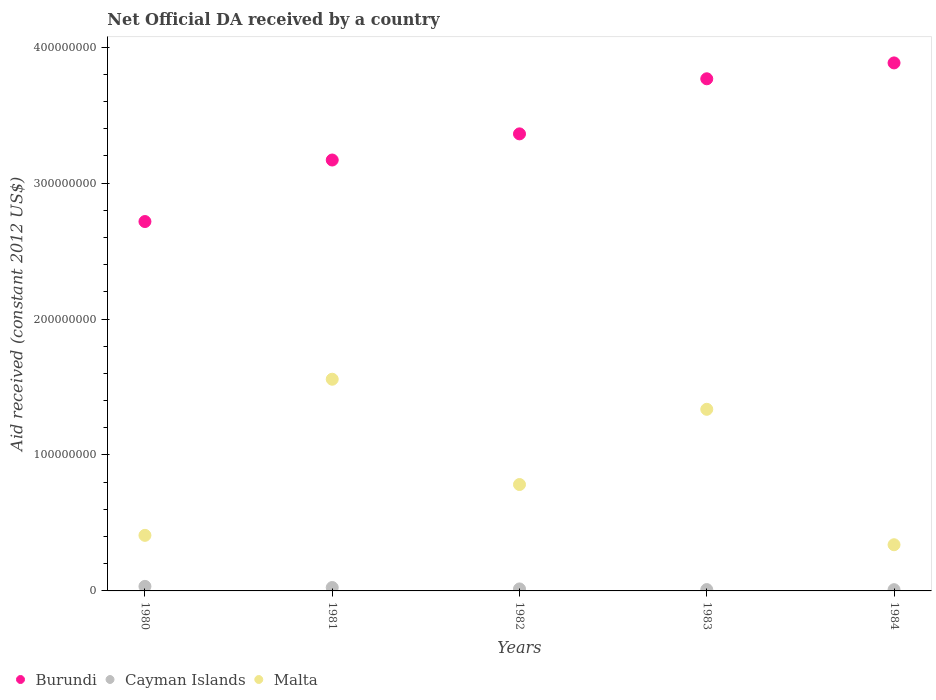Is the number of dotlines equal to the number of legend labels?
Your answer should be compact. Yes. What is the net official development assistance aid received in Cayman Islands in 1981?
Make the answer very short. 2.50e+06. Across all years, what is the maximum net official development assistance aid received in Cayman Islands?
Give a very brief answer. 3.34e+06. Across all years, what is the minimum net official development assistance aid received in Cayman Islands?
Give a very brief answer. 9.20e+05. What is the total net official development assistance aid received in Cayman Islands in the graph?
Your answer should be very brief. 9.21e+06. What is the difference between the net official development assistance aid received in Burundi in 1982 and that in 1984?
Provide a succinct answer. -5.22e+07. What is the difference between the net official development assistance aid received in Cayman Islands in 1981 and the net official development assistance aid received in Malta in 1980?
Make the answer very short. -3.84e+07. What is the average net official development assistance aid received in Burundi per year?
Provide a short and direct response. 3.38e+08. In the year 1984, what is the difference between the net official development assistance aid received in Cayman Islands and net official development assistance aid received in Burundi?
Offer a very short reply. -3.87e+08. What is the ratio of the net official development assistance aid received in Cayman Islands in 1980 to that in 1982?
Offer a terse response. 2.27. Is the net official development assistance aid received in Burundi in 1980 less than that in 1983?
Make the answer very short. Yes. Is the difference between the net official development assistance aid received in Cayman Islands in 1980 and 1981 greater than the difference between the net official development assistance aid received in Burundi in 1980 and 1981?
Offer a terse response. Yes. What is the difference between the highest and the second highest net official development assistance aid received in Cayman Islands?
Your answer should be very brief. 8.40e+05. What is the difference between the highest and the lowest net official development assistance aid received in Malta?
Provide a succinct answer. 1.22e+08. Is the sum of the net official development assistance aid received in Malta in 1980 and 1983 greater than the maximum net official development assistance aid received in Cayman Islands across all years?
Provide a succinct answer. Yes. Is it the case that in every year, the sum of the net official development assistance aid received in Cayman Islands and net official development assistance aid received in Burundi  is greater than the net official development assistance aid received in Malta?
Ensure brevity in your answer.  Yes. Is the net official development assistance aid received in Burundi strictly greater than the net official development assistance aid received in Cayman Islands over the years?
Keep it short and to the point. Yes. How many dotlines are there?
Provide a succinct answer. 3. How many years are there in the graph?
Offer a very short reply. 5. What is the difference between two consecutive major ticks on the Y-axis?
Your answer should be compact. 1.00e+08. Does the graph contain any zero values?
Provide a succinct answer. No. How many legend labels are there?
Offer a terse response. 3. How are the legend labels stacked?
Give a very brief answer. Horizontal. What is the title of the graph?
Keep it short and to the point. Net Official DA received by a country. Does "Sint Maarten (Dutch part)" appear as one of the legend labels in the graph?
Keep it short and to the point. No. What is the label or title of the Y-axis?
Your answer should be very brief. Aid received (constant 2012 US$). What is the Aid received (constant 2012 US$) of Burundi in 1980?
Offer a terse response. 2.72e+08. What is the Aid received (constant 2012 US$) in Cayman Islands in 1980?
Make the answer very short. 3.34e+06. What is the Aid received (constant 2012 US$) of Malta in 1980?
Give a very brief answer. 4.09e+07. What is the Aid received (constant 2012 US$) of Burundi in 1981?
Keep it short and to the point. 3.17e+08. What is the Aid received (constant 2012 US$) of Cayman Islands in 1981?
Provide a short and direct response. 2.50e+06. What is the Aid received (constant 2012 US$) of Malta in 1981?
Ensure brevity in your answer.  1.56e+08. What is the Aid received (constant 2012 US$) in Burundi in 1982?
Give a very brief answer. 3.36e+08. What is the Aid received (constant 2012 US$) in Cayman Islands in 1982?
Your answer should be very brief. 1.47e+06. What is the Aid received (constant 2012 US$) of Malta in 1982?
Offer a very short reply. 7.83e+07. What is the Aid received (constant 2012 US$) in Burundi in 1983?
Provide a succinct answer. 3.77e+08. What is the Aid received (constant 2012 US$) of Cayman Islands in 1983?
Offer a very short reply. 9.80e+05. What is the Aid received (constant 2012 US$) in Malta in 1983?
Provide a succinct answer. 1.34e+08. What is the Aid received (constant 2012 US$) in Burundi in 1984?
Give a very brief answer. 3.88e+08. What is the Aid received (constant 2012 US$) in Cayman Islands in 1984?
Give a very brief answer. 9.20e+05. What is the Aid received (constant 2012 US$) of Malta in 1984?
Your response must be concise. 3.40e+07. Across all years, what is the maximum Aid received (constant 2012 US$) in Burundi?
Your answer should be compact. 3.88e+08. Across all years, what is the maximum Aid received (constant 2012 US$) in Cayman Islands?
Provide a succinct answer. 3.34e+06. Across all years, what is the maximum Aid received (constant 2012 US$) in Malta?
Provide a succinct answer. 1.56e+08. Across all years, what is the minimum Aid received (constant 2012 US$) of Burundi?
Your answer should be very brief. 2.72e+08. Across all years, what is the minimum Aid received (constant 2012 US$) in Cayman Islands?
Make the answer very short. 9.20e+05. Across all years, what is the minimum Aid received (constant 2012 US$) of Malta?
Offer a very short reply. 3.40e+07. What is the total Aid received (constant 2012 US$) in Burundi in the graph?
Keep it short and to the point. 1.69e+09. What is the total Aid received (constant 2012 US$) of Cayman Islands in the graph?
Your answer should be very brief. 9.21e+06. What is the total Aid received (constant 2012 US$) of Malta in the graph?
Keep it short and to the point. 4.42e+08. What is the difference between the Aid received (constant 2012 US$) of Burundi in 1980 and that in 1981?
Provide a short and direct response. -4.52e+07. What is the difference between the Aid received (constant 2012 US$) of Cayman Islands in 1980 and that in 1981?
Make the answer very short. 8.40e+05. What is the difference between the Aid received (constant 2012 US$) in Malta in 1980 and that in 1981?
Offer a terse response. -1.15e+08. What is the difference between the Aid received (constant 2012 US$) in Burundi in 1980 and that in 1982?
Ensure brevity in your answer.  -6.45e+07. What is the difference between the Aid received (constant 2012 US$) in Cayman Islands in 1980 and that in 1982?
Offer a terse response. 1.87e+06. What is the difference between the Aid received (constant 2012 US$) of Malta in 1980 and that in 1982?
Offer a terse response. -3.74e+07. What is the difference between the Aid received (constant 2012 US$) in Burundi in 1980 and that in 1983?
Ensure brevity in your answer.  -1.05e+08. What is the difference between the Aid received (constant 2012 US$) of Cayman Islands in 1980 and that in 1983?
Your answer should be compact. 2.36e+06. What is the difference between the Aid received (constant 2012 US$) of Malta in 1980 and that in 1983?
Provide a short and direct response. -9.27e+07. What is the difference between the Aid received (constant 2012 US$) of Burundi in 1980 and that in 1984?
Provide a short and direct response. -1.17e+08. What is the difference between the Aid received (constant 2012 US$) in Cayman Islands in 1980 and that in 1984?
Provide a short and direct response. 2.42e+06. What is the difference between the Aid received (constant 2012 US$) of Malta in 1980 and that in 1984?
Your answer should be compact. 6.90e+06. What is the difference between the Aid received (constant 2012 US$) in Burundi in 1981 and that in 1982?
Keep it short and to the point. -1.92e+07. What is the difference between the Aid received (constant 2012 US$) of Cayman Islands in 1981 and that in 1982?
Offer a terse response. 1.03e+06. What is the difference between the Aid received (constant 2012 US$) of Malta in 1981 and that in 1982?
Offer a very short reply. 7.74e+07. What is the difference between the Aid received (constant 2012 US$) in Burundi in 1981 and that in 1983?
Ensure brevity in your answer.  -5.97e+07. What is the difference between the Aid received (constant 2012 US$) of Cayman Islands in 1981 and that in 1983?
Provide a short and direct response. 1.52e+06. What is the difference between the Aid received (constant 2012 US$) in Malta in 1981 and that in 1983?
Your answer should be compact. 2.21e+07. What is the difference between the Aid received (constant 2012 US$) of Burundi in 1981 and that in 1984?
Offer a terse response. -7.14e+07. What is the difference between the Aid received (constant 2012 US$) of Cayman Islands in 1981 and that in 1984?
Your answer should be compact. 1.58e+06. What is the difference between the Aid received (constant 2012 US$) in Malta in 1981 and that in 1984?
Provide a short and direct response. 1.22e+08. What is the difference between the Aid received (constant 2012 US$) of Burundi in 1982 and that in 1983?
Ensure brevity in your answer.  -4.05e+07. What is the difference between the Aid received (constant 2012 US$) in Cayman Islands in 1982 and that in 1983?
Your answer should be very brief. 4.90e+05. What is the difference between the Aid received (constant 2012 US$) in Malta in 1982 and that in 1983?
Your response must be concise. -5.53e+07. What is the difference between the Aid received (constant 2012 US$) in Burundi in 1982 and that in 1984?
Your answer should be very brief. -5.22e+07. What is the difference between the Aid received (constant 2012 US$) in Malta in 1982 and that in 1984?
Keep it short and to the point. 4.43e+07. What is the difference between the Aid received (constant 2012 US$) in Burundi in 1983 and that in 1984?
Your answer should be very brief. -1.17e+07. What is the difference between the Aid received (constant 2012 US$) of Cayman Islands in 1983 and that in 1984?
Provide a succinct answer. 6.00e+04. What is the difference between the Aid received (constant 2012 US$) in Malta in 1983 and that in 1984?
Provide a short and direct response. 9.96e+07. What is the difference between the Aid received (constant 2012 US$) in Burundi in 1980 and the Aid received (constant 2012 US$) in Cayman Islands in 1981?
Make the answer very short. 2.69e+08. What is the difference between the Aid received (constant 2012 US$) in Burundi in 1980 and the Aid received (constant 2012 US$) in Malta in 1981?
Offer a very short reply. 1.16e+08. What is the difference between the Aid received (constant 2012 US$) of Cayman Islands in 1980 and the Aid received (constant 2012 US$) of Malta in 1981?
Your answer should be very brief. -1.52e+08. What is the difference between the Aid received (constant 2012 US$) in Burundi in 1980 and the Aid received (constant 2012 US$) in Cayman Islands in 1982?
Give a very brief answer. 2.70e+08. What is the difference between the Aid received (constant 2012 US$) of Burundi in 1980 and the Aid received (constant 2012 US$) of Malta in 1982?
Make the answer very short. 1.93e+08. What is the difference between the Aid received (constant 2012 US$) in Cayman Islands in 1980 and the Aid received (constant 2012 US$) in Malta in 1982?
Your answer should be compact. -7.49e+07. What is the difference between the Aid received (constant 2012 US$) of Burundi in 1980 and the Aid received (constant 2012 US$) of Cayman Islands in 1983?
Offer a terse response. 2.71e+08. What is the difference between the Aid received (constant 2012 US$) of Burundi in 1980 and the Aid received (constant 2012 US$) of Malta in 1983?
Offer a very short reply. 1.38e+08. What is the difference between the Aid received (constant 2012 US$) of Cayman Islands in 1980 and the Aid received (constant 2012 US$) of Malta in 1983?
Keep it short and to the point. -1.30e+08. What is the difference between the Aid received (constant 2012 US$) of Burundi in 1980 and the Aid received (constant 2012 US$) of Cayman Islands in 1984?
Give a very brief answer. 2.71e+08. What is the difference between the Aid received (constant 2012 US$) in Burundi in 1980 and the Aid received (constant 2012 US$) in Malta in 1984?
Your answer should be very brief. 2.38e+08. What is the difference between the Aid received (constant 2012 US$) of Cayman Islands in 1980 and the Aid received (constant 2012 US$) of Malta in 1984?
Give a very brief answer. -3.06e+07. What is the difference between the Aid received (constant 2012 US$) in Burundi in 1981 and the Aid received (constant 2012 US$) in Cayman Islands in 1982?
Give a very brief answer. 3.15e+08. What is the difference between the Aid received (constant 2012 US$) of Burundi in 1981 and the Aid received (constant 2012 US$) of Malta in 1982?
Ensure brevity in your answer.  2.39e+08. What is the difference between the Aid received (constant 2012 US$) in Cayman Islands in 1981 and the Aid received (constant 2012 US$) in Malta in 1982?
Offer a terse response. -7.58e+07. What is the difference between the Aid received (constant 2012 US$) of Burundi in 1981 and the Aid received (constant 2012 US$) of Cayman Islands in 1983?
Keep it short and to the point. 3.16e+08. What is the difference between the Aid received (constant 2012 US$) in Burundi in 1981 and the Aid received (constant 2012 US$) in Malta in 1983?
Offer a terse response. 1.83e+08. What is the difference between the Aid received (constant 2012 US$) in Cayman Islands in 1981 and the Aid received (constant 2012 US$) in Malta in 1983?
Make the answer very short. -1.31e+08. What is the difference between the Aid received (constant 2012 US$) of Burundi in 1981 and the Aid received (constant 2012 US$) of Cayman Islands in 1984?
Offer a very short reply. 3.16e+08. What is the difference between the Aid received (constant 2012 US$) of Burundi in 1981 and the Aid received (constant 2012 US$) of Malta in 1984?
Keep it short and to the point. 2.83e+08. What is the difference between the Aid received (constant 2012 US$) in Cayman Islands in 1981 and the Aid received (constant 2012 US$) in Malta in 1984?
Your answer should be very brief. -3.15e+07. What is the difference between the Aid received (constant 2012 US$) in Burundi in 1982 and the Aid received (constant 2012 US$) in Cayman Islands in 1983?
Provide a succinct answer. 3.35e+08. What is the difference between the Aid received (constant 2012 US$) in Burundi in 1982 and the Aid received (constant 2012 US$) in Malta in 1983?
Provide a succinct answer. 2.03e+08. What is the difference between the Aid received (constant 2012 US$) in Cayman Islands in 1982 and the Aid received (constant 2012 US$) in Malta in 1983?
Give a very brief answer. -1.32e+08. What is the difference between the Aid received (constant 2012 US$) of Burundi in 1982 and the Aid received (constant 2012 US$) of Cayman Islands in 1984?
Your answer should be very brief. 3.35e+08. What is the difference between the Aid received (constant 2012 US$) of Burundi in 1982 and the Aid received (constant 2012 US$) of Malta in 1984?
Provide a short and direct response. 3.02e+08. What is the difference between the Aid received (constant 2012 US$) of Cayman Islands in 1982 and the Aid received (constant 2012 US$) of Malta in 1984?
Keep it short and to the point. -3.25e+07. What is the difference between the Aid received (constant 2012 US$) of Burundi in 1983 and the Aid received (constant 2012 US$) of Cayman Islands in 1984?
Offer a terse response. 3.76e+08. What is the difference between the Aid received (constant 2012 US$) in Burundi in 1983 and the Aid received (constant 2012 US$) in Malta in 1984?
Give a very brief answer. 3.43e+08. What is the difference between the Aid received (constant 2012 US$) of Cayman Islands in 1983 and the Aid received (constant 2012 US$) of Malta in 1984?
Your answer should be compact. -3.30e+07. What is the average Aid received (constant 2012 US$) of Burundi per year?
Provide a succinct answer. 3.38e+08. What is the average Aid received (constant 2012 US$) of Cayman Islands per year?
Your response must be concise. 1.84e+06. What is the average Aid received (constant 2012 US$) in Malta per year?
Ensure brevity in your answer.  8.85e+07. In the year 1980, what is the difference between the Aid received (constant 2012 US$) in Burundi and Aid received (constant 2012 US$) in Cayman Islands?
Provide a succinct answer. 2.68e+08. In the year 1980, what is the difference between the Aid received (constant 2012 US$) in Burundi and Aid received (constant 2012 US$) in Malta?
Provide a succinct answer. 2.31e+08. In the year 1980, what is the difference between the Aid received (constant 2012 US$) in Cayman Islands and Aid received (constant 2012 US$) in Malta?
Your response must be concise. -3.75e+07. In the year 1981, what is the difference between the Aid received (constant 2012 US$) in Burundi and Aid received (constant 2012 US$) in Cayman Islands?
Keep it short and to the point. 3.14e+08. In the year 1981, what is the difference between the Aid received (constant 2012 US$) in Burundi and Aid received (constant 2012 US$) in Malta?
Offer a very short reply. 1.61e+08. In the year 1981, what is the difference between the Aid received (constant 2012 US$) of Cayman Islands and Aid received (constant 2012 US$) of Malta?
Offer a terse response. -1.53e+08. In the year 1982, what is the difference between the Aid received (constant 2012 US$) in Burundi and Aid received (constant 2012 US$) in Cayman Islands?
Ensure brevity in your answer.  3.35e+08. In the year 1982, what is the difference between the Aid received (constant 2012 US$) in Burundi and Aid received (constant 2012 US$) in Malta?
Give a very brief answer. 2.58e+08. In the year 1982, what is the difference between the Aid received (constant 2012 US$) of Cayman Islands and Aid received (constant 2012 US$) of Malta?
Ensure brevity in your answer.  -7.68e+07. In the year 1983, what is the difference between the Aid received (constant 2012 US$) of Burundi and Aid received (constant 2012 US$) of Cayman Islands?
Provide a succinct answer. 3.76e+08. In the year 1983, what is the difference between the Aid received (constant 2012 US$) in Burundi and Aid received (constant 2012 US$) in Malta?
Offer a terse response. 2.43e+08. In the year 1983, what is the difference between the Aid received (constant 2012 US$) of Cayman Islands and Aid received (constant 2012 US$) of Malta?
Ensure brevity in your answer.  -1.33e+08. In the year 1984, what is the difference between the Aid received (constant 2012 US$) of Burundi and Aid received (constant 2012 US$) of Cayman Islands?
Your response must be concise. 3.87e+08. In the year 1984, what is the difference between the Aid received (constant 2012 US$) in Burundi and Aid received (constant 2012 US$) in Malta?
Offer a very short reply. 3.54e+08. In the year 1984, what is the difference between the Aid received (constant 2012 US$) of Cayman Islands and Aid received (constant 2012 US$) of Malta?
Offer a terse response. -3.30e+07. What is the ratio of the Aid received (constant 2012 US$) of Burundi in 1980 to that in 1981?
Ensure brevity in your answer.  0.86. What is the ratio of the Aid received (constant 2012 US$) in Cayman Islands in 1980 to that in 1981?
Provide a succinct answer. 1.34. What is the ratio of the Aid received (constant 2012 US$) of Malta in 1980 to that in 1981?
Give a very brief answer. 0.26. What is the ratio of the Aid received (constant 2012 US$) in Burundi in 1980 to that in 1982?
Your response must be concise. 0.81. What is the ratio of the Aid received (constant 2012 US$) in Cayman Islands in 1980 to that in 1982?
Your response must be concise. 2.27. What is the ratio of the Aid received (constant 2012 US$) of Malta in 1980 to that in 1982?
Give a very brief answer. 0.52. What is the ratio of the Aid received (constant 2012 US$) of Burundi in 1980 to that in 1983?
Offer a terse response. 0.72. What is the ratio of the Aid received (constant 2012 US$) in Cayman Islands in 1980 to that in 1983?
Your response must be concise. 3.41. What is the ratio of the Aid received (constant 2012 US$) in Malta in 1980 to that in 1983?
Your answer should be very brief. 0.31. What is the ratio of the Aid received (constant 2012 US$) in Burundi in 1980 to that in 1984?
Provide a succinct answer. 0.7. What is the ratio of the Aid received (constant 2012 US$) of Cayman Islands in 1980 to that in 1984?
Ensure brevity in your answer.  3.63. What is the ratio of the Aid received (constant 2012 US$) in Malta in 1980 to that in 1984?
Your answer should be very brief. 1.2. What is the ratio of the Aid received (constant 2012 US$) of Burundi in 1981 to that in 1982?
Your answer should be very brief. 0.94. What is the ratio of the Aid received (constant 2012 US$) of Cayman Islands in 1981 to that in 1982?
Give a very brief answer. 1.7. What is the ratio of the Aid received (constant 2012 US$) in Malta in 1981 to that in 1982?
Offer a very short reply. 1.99. What is the ratio of the Aid received (constant 2012 US$) in Burundi in 1981 to that in 1983?
Offer a very short reply. 0.84. What is the ratio of the Aid received (constant 2012 US$) in Cayman Islands in 1981 to that in 1983?
Your answer should be very brief. 2.55. What is the ratio of the Aid received (constant 2012 US$) in Malta in 1981 to that in 1983?
Your answer should be compact. 1.17. What is the ratio of the Aid received (constant 2012 US$) in Burundi in 1981 to that in 1984?
Provide a short and direct response. 0.82. What is the ratio of the Aid received (constant 2012 US$) in Cayman Islands in 1981 to that in 1984?
Offer a terse response. 2.72. What is the ratio of the Aid received (constant 2012 US$) in Malta in 1981 to that in 1984?
Make the answer very short. 4.58. What is the ratio of the Aid received (constant 2012 US$) in Burundi in 1982 to that in 1983?
Offer a terse response. 0.89. What is the ratio of the Aid received (constant 2012 US$) of Cayman Islands in 1982 to that in 1983?
Offer a terse response. 1.5. What is the ratio of the Aid received (constant 2012 US$) of Malta in 1982 to that in 1983?
Your response must be concise. 0.59. What is the ratio of the Aid received (constant 2012 US$) in Burundi in 1982 to that in 1984?
Your answer should be compact. 0.87. What is the ratio of the Aid received (constant 2012 US$) of Cayman Islands in 1982 to that in 1984?
Make the answer very short. 1.6. What is the ratio of the Aid received (constant 2012 US$) of Malta in 1982 to that in 1984?
Your response must be concise. 2.3. What is the ratio of the Aid received (constant 2012 US$) of Burundi in 1983 to that in 1984?
Make the answer very short. 0.97. What is the ratio of the Aid received (constant 2012 US$) of Cayman Islands in 1983 to that in 1984?
Make the answer very short. 1.07. What is the ratio of the Aid received (constant 2012 US$) of Malta in 1983 to that in 1984?
Your answer should be very brief. 3.93. What is the difference between the highest and the second highest Aid received (constant 2012 US$) of Burundi?
Your response must be concise. 1.17e+07. What is the difference between the highest and the second highest Aid received (constant 2012 US$) of Cayman Islands?
Offer a very short reply. 8.40e+05. What is the difference between the highest and the second highest Aid received (constant 2012 US$) in Malta?
Offer a very short reply. 2.21e+07. What is the difference between the highest and the lowest Aid received (constant 2012 US$) of Burundi?
Your answer should be compact. 1.17e+08. What is the difference between the highest and the lowest Aid received (constant 2012 US$) of Cayman Islands?
Your response must be concise. 2.42e+06. What is the difference between the highest and the lowest Aid received (constant 2012 US$) of Malta?
Give a very brief answer. 1.22e+08. 